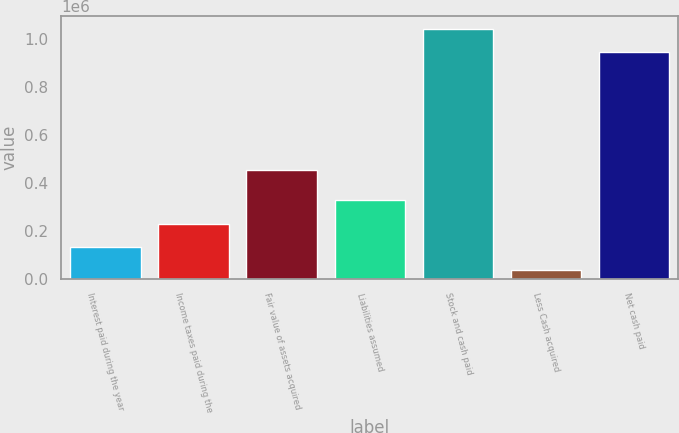<chart> <loc_0><loc_0><loc_500><loc_500><bar_chart><fcel>Interest paid during the year<fcel>Income taxes paid during the<fcel>Fair value of assets acquired<fcel>Liabilities assumed<fcel>Stock and cash paid<fcel>Less Cash acquired<fcel>Net cash paid<nl><fcel>132488<fcel>229568<fcel>452209<fcel>326648<fcel>1.04238e+06<fcel>35408<fcel>945299<nl></chart> 